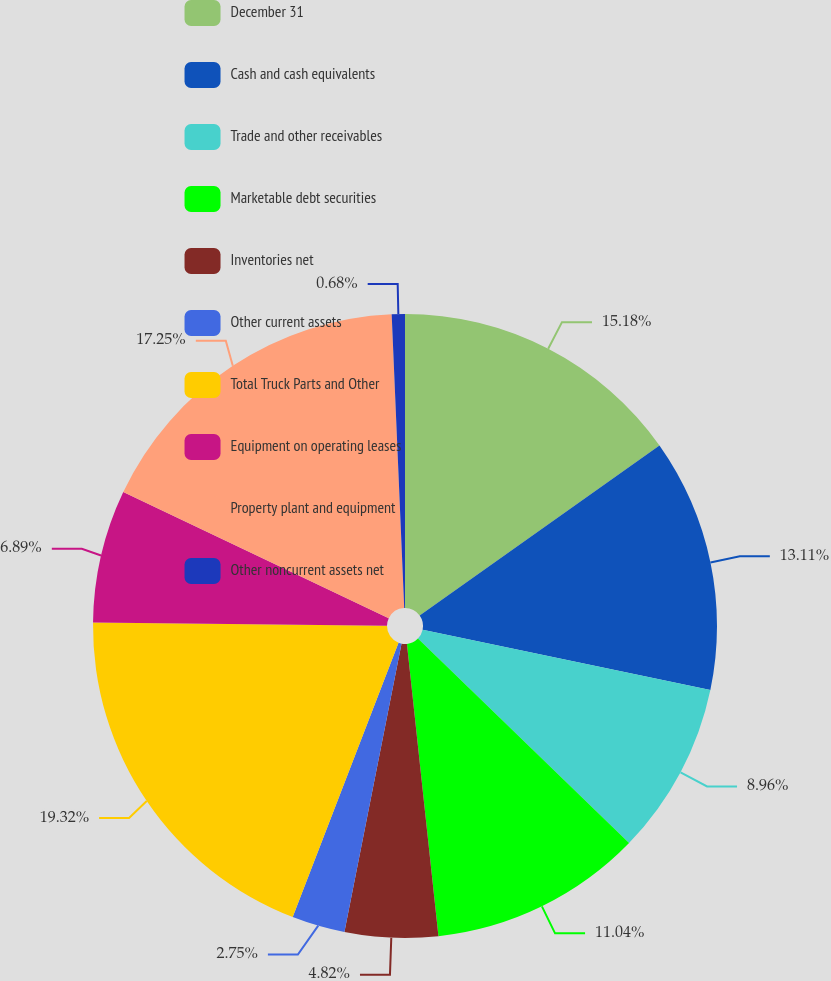Convert chart to OTSL. <chart><loc_0><loc_0><loc_500><loc_500><pie_chart><fcel>December 31<fcel>Cash and cash equivalents<fcel>Trade and other receivables<fcel>Marketable debt securities<fcel>Inventories net<fcel>Other current assets<fcel>Total Truck Parts and Other<fcel>Equipment on operating leases<fcel>Property plant and equipment<fcel>Other noncurrent assets net<nl><fcel>15.18%<fcel>13.11%<fcel>8.96%<fcel>11.04%<fcel>4.82%<fcel>2.75%<fcel>19.32%<fcel>6.89%<fcel>17.25%<fcel>0.68%<nl></chart> 